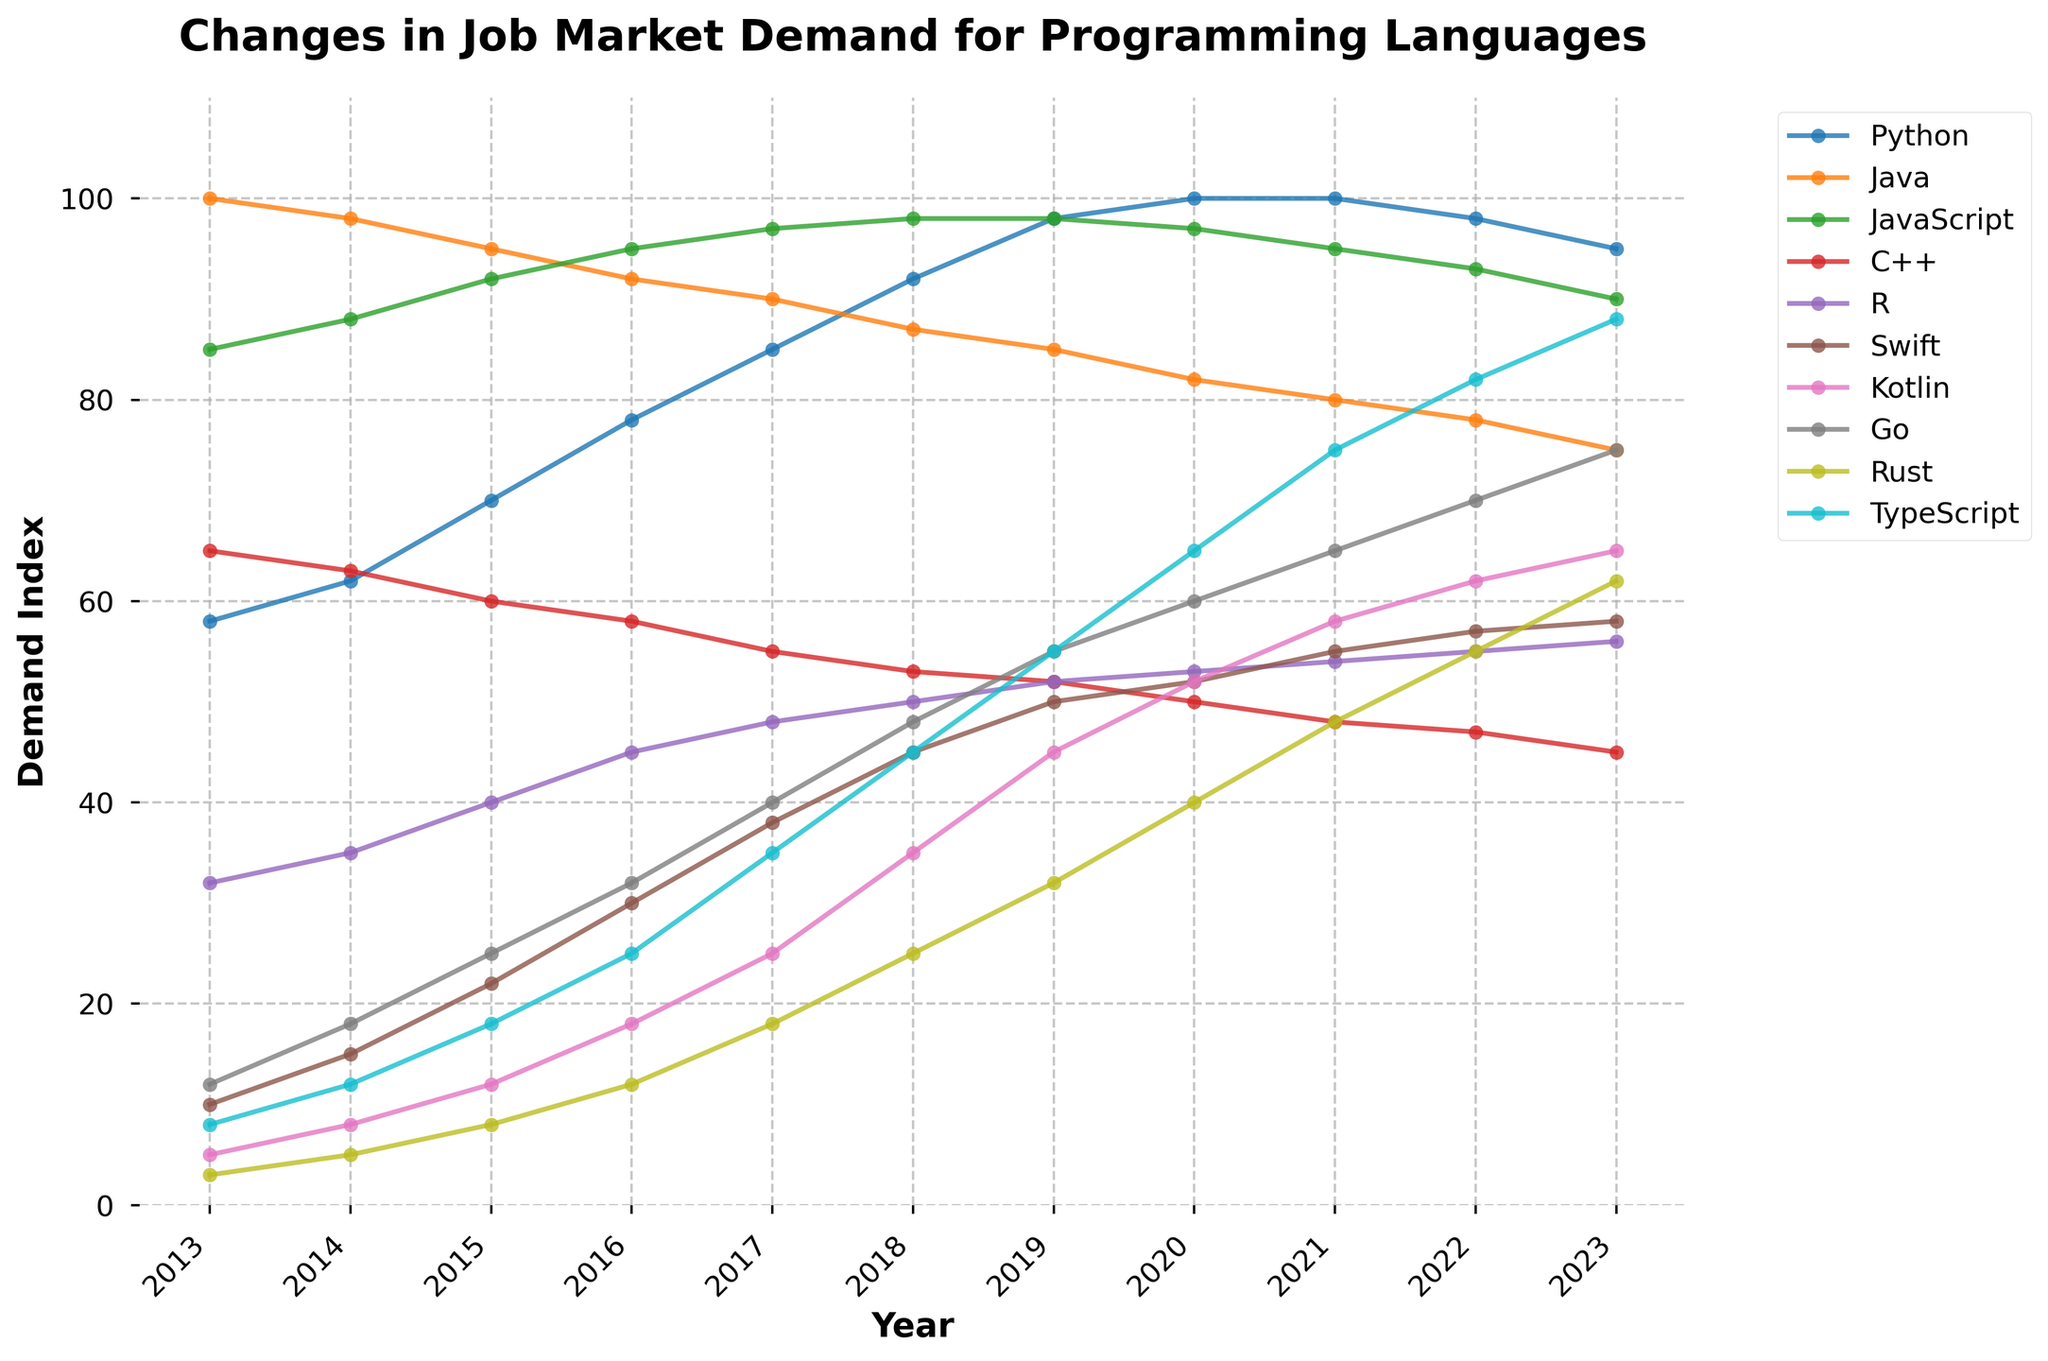Which programming language experienced the highest job market demand in 2020? Looking at the year 2020 on the x-axis, the programming language with the highest data point (y-axis) indicates the highest demand. Python is the language at the highest level.
Answer: Python Which programming language had the greatest increase in job market demand from 2013 to 2023? To determine this, we need to look at the difference between demand in 2013 and 2023 for each language and find the largest difference. Rust's demand increased from 3 in 2013 to 62 in 2023, which is the greatest increase.
Answer: Rust Compare the job market demand for Java and Python in 2023. Which one is more in demand and by how much? In 2023, Python has a demand index of 95, while Java has a demand index of 75. Subtracting Java's demand from Python's, 95 - 75 = 20. Thus, Python is more in demand by 20 points.
Answer: Python by 20 How did the demand for Python change from 2013 to 2023 compared to the demand for C++ over the same period? Python's demand increased from 58 in 2013 to 95 in 2023, an increase of 37 points. C++'s demand decreased from 65 in 2013 to 45 in 2023, a decrease of 20 points. Hence, Python's demand increased by 37 points while C++'s fell by 20 points.
Answer: Python increased by 37, C++ decreased by 20 Identify the years in which Go's job market demand overtook that of C++. Looking at the intersection points on the graph for Go and C++: Go overtakes C++ in the years 2018, 2019, 2020, 2021, 2022, and 2023 as observed from higher plotted lines for Go over C++ in these years.
Answer: 2018, 2019, 2020, 2021, 2022, 2023 What is the average job market demand for JavaScript from 2013 to 2023? Sum the job market demand data for JavaScript over these years: 85 + 88 + 92 + 95 + 97 + 98 + 98 + 97 + 95 + 93 + 90 = 1028. Divide by the number of years, 1028 / 11 ≈ 93.45.
Answer: 93.45 Which two programming languages had the closest job market demand in 2023, and what was the difference? Comparing 2023 values: Python (95), Java (75), JavaScript (90), C++ (45), R (56), Swift (58), Kotlin (65), Go (75), Rust (62), TypeScript (88), the closest pair is Swift (58) and R (56) with a difference of 2 points.
Answer: Swift and R, difference of 2 What trend do you observe for Kotlin's job market demand from 2013 to 2023? Observing Kotlin's demand from 2013 (5) steadily increasing each consecutive year to reach 65 in 2023 indicates a consistent upward trend.
Answer: Upward trend Between Python and TypeScript, which programming language saw its peak job market demand in a different year compared to the other, and what years were they? Python peaked in 2020 and stayed at 100 until 2021. TypeScript continued to increase and peaked in 2023 at 88.
Answer: Python: 2020, TypeScript: 2023 